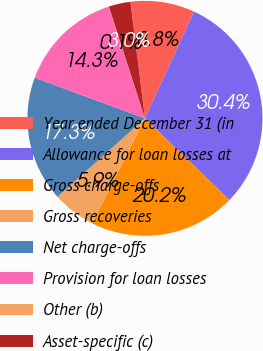<chart> <loc_0><loc_0><loc_500><loc_500><pie_chart><fcel>Year ended December 31 (in<fcel>Allowance for loan losses at<fcel>Gross charge-offs<fcel>Gross recoveries<fcel>Net charge-offs<fcel>Provision for loan losses<fcel>Other (b)<fcel>Asset-specific (c)<nl><fcel>8.85%<fcel>30.38%<fcel>20.2%<fcel>5.92%<fcel>17.27%<fcel>14.34%<fcel>0.06%<fcel>2.99%<nl></chart> 